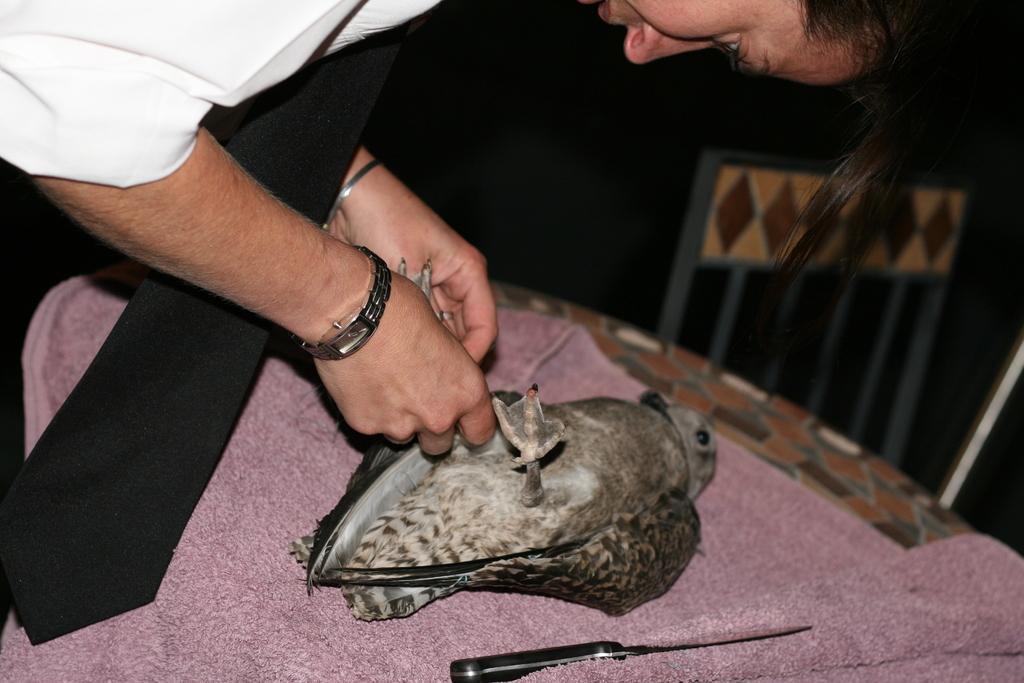Describe this image in one or two sentences. In this picture I can see a woman holding a bird which is placed on the table, side we can see a knife. 